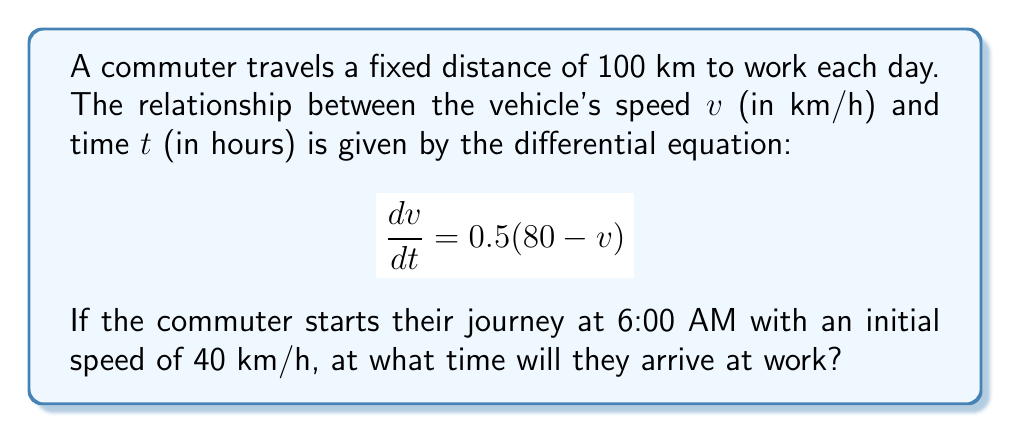Can you solve this math problem? To solve this problem, we need to follow these steps:

1) First, solve the differential equation for $v(t)$:
   The given equation is a first-order linear differential equation.
   $$\frac{dv}{dt} = 0.5(80 - v)$$
   $$\frac{dv}{80 - v} = 0.5dt$$
   Integrating both sides:
   $$-2\ln|80 - v| = t + C$$
   $$80 - v = Ae^{-0.5t}$$
   $$v = 80 - Ae^{-0.5t}$$
   
   Using the initial condition $v(0) = 40$:
   $$40 = 80 - A$$
   $$A = 40$$
   
   Therefore, the solution is:
   $$v(t) = 80 - 40e^{-0.5t}$$

2) Now, we need to find the time taken to travel 100 km. We can do this by integrating $\frac{1}{v}$ with respect to distance:
   $$t = \int_0^{100} \frac{1}{v} ds$$
   
   Substituting our expression for $v$:
   $$t = \int_0^{100} \frac{1}{80 - 40e^{-0.5t}} ds$$
   
   This integral is difficult to solve analytically. We can solve it numerically using a computer or calculator.

3) Using numerical methods, we find that $t \approx 1.62$ hours.

4) Since the commuter started at 6:00 AM, they will arrive at work at approximately 7:37 AM (6:00 AM + 1 hour 37 minutes).
Answer: The commuter will arrive at work at approximately 7:37 AM. 